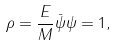Convert formula to latex. <formula><loc_0><loc_0><loc_500><loc_500>\rho = \frac { E } { M } \bar { \psi } \psi = 1 ,</formula> 